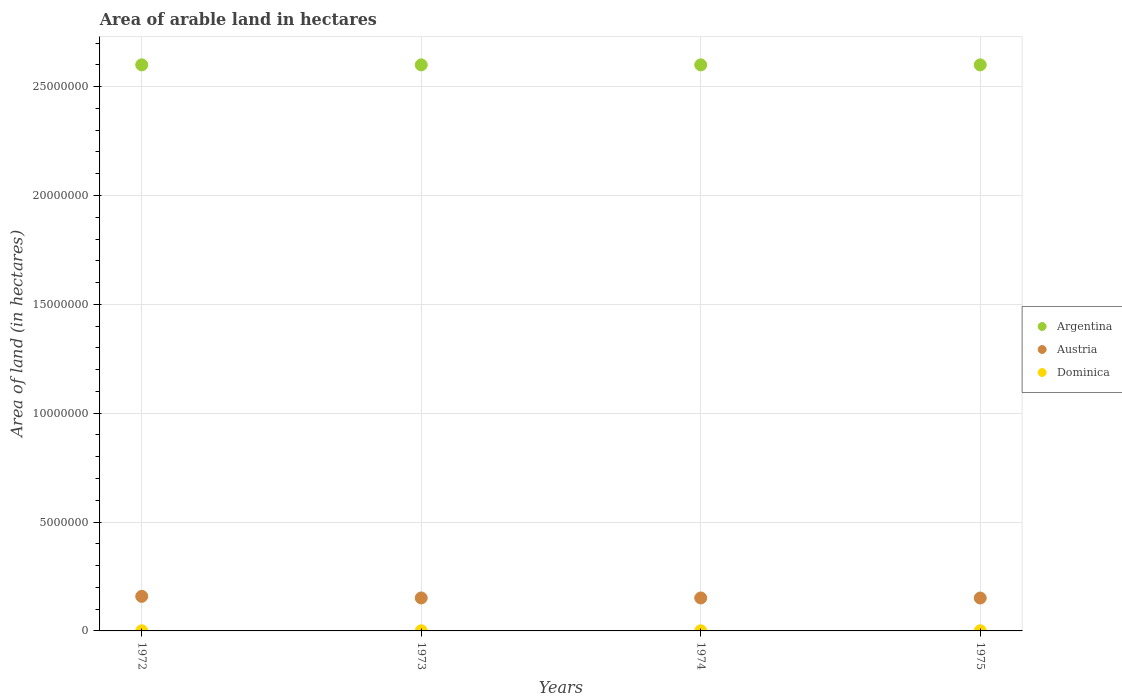How many different coloured dotlines are there?
Your response must be concise. 3. What is the total arable land in Dominica in 1974?
Provide a short and direct response. 7000. Across all years, what is the maximum total arable land in Argentina?
Your response must be concise. 2.60e+07. Across all years, what is the minimum total arable land in Dominica?
Your response must be concise. 7000. In which year was the total arable land in Austria minimum?
Provide a short and direct response. 1975. What is the total total arable land in Argentina in the graph?
Give a very brief answer. 1.04e+08. What is the difference between the total arable land in Dominica in 1973 and the total arable land in Austria in 1972?
Make the answer very short. -1.58e+06. What is the average total arable land in Austria per year?
Provide a succinct answer. 1.53e+06. In the year 1972, what is the difference between the total arable land in Austria and total arable land in Dominica?
Your answer should be compact. 1.58e+06. Is the total arable land in Argentina in 1974 less than that in 1975?
Your answer should be very brief. No. Is the difference between the total arable land in Austria in 1974 and 1975 greater than the difference between the total arable land in Dominica in 1974 and 1975?
Offer a very short reply. Yes. What is the difference between the highest and the lowest total arable land in Argentina?
Ensure brevity in your answer.  0. Is the total arable land in Argentina strictly less than the total arable land in Austria over the years?
Provide a short and direct response. No. How many dotlines are there?
Keep it short and to the point. 3. Does the graph contain any zero values?
Offer a very short reply. No. Does the graph contain grids?
Make the answer very short. Yes. Where does the legend appear in the graph?
Your response must be concise. Center right. What is the title of the graph?
Your response must be concise. Area of arable land in hectares. Does "Sri Lanka" appear as one of the legend labels in the graph?
Keep it short and to the point. No. What is the label or title of the X-axis?
Keep it short and to the point. Years. What is the label or title of the Y-axis?
Make the answer very short. Area of land (in hectares). What is the Area of land (in hectares) in Argentina in 1972?
Offer a very short reply. 2.60e+07. What is the Area of land (in hectares) in Austria in 1972?
Your answer should be compact. 1.59e+06. What is the Area of land (in hectares) of Dominica in 1972?
Your answer should be compact. 7000. What is the Area of land (in hectares) in Argentina in 1973?
Provide a succinct answer. 2.60e+07. What is the Area of land (in hectares) of Austria in 1973?
Ensure brevity in your answer.  1.51e+06. What is the Area of land (in hectares) of Dominica in 1973?
Provide a succinct answer. 7000. What is the Area of land (in hectares) of Argentina in 1974?
Offer a terse response. 2.60e+07. What is the Area of land (in hectares) in Austria in 1974?
Your answer should be very brief. 1.51e+06. What is the Area of land (in hectares) of Dominica in 1974?
Your response must be concise. 7000. What is the Area of land (in hectares) of Argentina in 1975?
Your answer should be compact. 2.60e+07. What is the Area of land (in hectares) in Austria in 1975?
Make the answer very short. 1.51e+06. What is the Area of land (in hectares) of Dominica in 1975?
Offer a very short reply. 7000. Across all years, what is the maximum Area of land (in hectares) of Argentina?
Keep it short and to the point. 2.60e+07. Across all years, what is the maximum Area of land (in hectares) in Austria?
Keep it short and to the point. 1.59e+06. Across all years, what is the maximum Area of land (in hectares) in Dominica?
Give a very brief answer. 7000. Across all years, what is the minimum Area of land (in hectares) in Argentina?
Provide a succinct answer. 2.60e+07. Across all years, what is the minimum Area of land (in hectares) in Austria?
Offer a very short reply. 1.51e+06. Across all years, what is the minimum Area of land (in hectares) of Dominica?
Keep it short and to the point. 7000. What is the total Area of land (in hectares) in Argentina in the graph?
Make the answer very short. 1.04e+08. What is the total Area of land (in hectares) of Austria in the graph?
Your response must be concise. 6.13e+06. What is the total Area of land (in hectares) of Dominica in the graph?
Your response must be concise. 2.80e+04. What is the difference between the Area of land (in hectares) in Argentina in 1972 and that in 1973?
Ensure brevity in your answer.  0. What is the difference between the Area of land (in hectares) of Austria in 1972 and that in 1973?
Offer a very short reply. 7.40e+04. What is the difference between the Area of land (in hectares) in Argentina in 1972 and that in 1974?
Your answer should be very brief. 0. What is the difference between the Area of land (in hectares) in Austria in 1972 and that in 1974?
Ensure brevity in your answer.  7.40e+04. What is the difference between the Area of land (in hectares) of Argentina in 1972 and that in 1975?
Provide a short and direct response. 0. What is the difference between the Area of land (in hectares) in Austria in 1972 and that in 1975?
Your answer should be very brief. 7.70e+04. What is the difference between the Area of land (in hectares) of Dominica in 1972 and that in 1975?
Make the answer very short. 0. What is the difference between the Area of land (in hectares) of Dominica in 1973 and that in 1974?
Give a very brief answer. 0. What is the difference between the Area of land (in hectares) in Austria in 1973 and that in 1975?
Keep it short and to the point. 3000. What is the difference between the Area of land (in hectares) of Austria in 1974 and that in 1975?
Your answer should be compact. 3000. What is the difference between the Area of land (in hectares) of Argentina in 1972 and the Area of land (in hectares) of Austria in 1973?
Keep it short and to the point. 2.45e+07. What is the difference between the Area of land (in hectares) of Argentina in 1972 and the Area of land (in hectares) of Dominica in 1973?
Your answer should be very brief. 2.60e+07. What is the difference between the Area of land (in hectares) of Austria in 1972 and the Area of land (in hectares) of Dominica in 1973?
Your answer should be compact. 1.58e+06. What is the difference between the Area of land (in hectares) of Argentina in 1972 and the Area of land (in hectares) of Austria in 1974?
Your answer should be compact. 2.45e+07. What is the difference between the Area of land (in hectares) in Argentina in 1972 and the Area of land (in hectares) in Dominica in 1974?
Give a very brief answer. 2.60e+07. What is the difference between the Area of land (in hectares) in Austria in 1972 and the Area of land (in hectares) in Dominica in 1974?
Your response must be concise. 1.58e+06. What is the difference between the Area of land (in hectares) of Argentina in 1972 and the Area of land (in hectares) of Austria in 1975?
Your answer should be compact. 2.45e+07. What is the difference between the Area of land (in hectares) of Argentina in 1972 and the Area of land (in hectares) of Dominica in 1975?
Your answer should be very brief. 2.60e+07. What is the difference between the Area of land (in hectares) of Austria in 1972 and the Area of land (in hectares) of Dominica in 1975?
Your answer should be very brief. 1.58e+06. What is the difference between the Area of land (in hectares) in Argentina in 1973 and the Area of land (in hectares) in Austria in 1974?
Keep it short and to the point. 2.45e+07. What is the difference between the Area of land (in hectares) in Argentina in 1973 and the Area of land (in hectares) in Dominica in 1974?
Give a very brief answer. 2.60e+07. What is the difference between the Area of land (in hectares) in Austria in 1973 and the Area of land (in hectares) in Dominica in 1974?
Provide a short and direct response. 1.51e+06. What is the difference between the Area of land (in hectares) in Argentina in 1973 and the Area of land (in hectares) in Austria in 1975?
Give a very brief answer. 2.45e+07. What is the difference between the Area of land (in hectares) of Argentina in 1973 and the Area of land (in hectares) of Dominica in 1975?
Give a very brief answer. 2.60e+07. What is the difference between the Area of land (in hectares) in Austria in 1973 and the Area of land (in hectares) in Dominica in 1975?
Provide a succinct answer. 1.51e+06. What is the difference between the Area of land (in hectares) in Argentina in 1974 and the Area of land (in hectares) in Austria in 1975?
Make the answer very short. 2.45e+07. What is the difference between the Area of land (in hectares) of Argentina in 1974 and the Area of land (in hectares) of Dominica in 1975?
Your response must be concise. 2.60e+07. What is the difference between the Area of land (in hectares) in Austria in 1974 and the Area of land (in hectares) in Dominica in 1975?
Provide a short and direct response. 1.51e+06. What is the average Area of land (in hectares) in Argentina per year?
Offer a terse response. 2.60e+07. What is the average Area of land (in hectares) in Austria per year?
Provide a short and direct response. 1.53e+06. What is the average Area of land (in hectares) in Dominica per year?
Offer a terse response. 7000. In the year 1972, what is the difference between the Area of land (in hectares) in Argentina and Area of land (in hectares) in Austria?
Offer a terse response. 2.44e+07. In the year 1972, what is the difference between the Area of land (in hectares) in Argentina and Area of land (in hectares) in Dominica?
Your answer should be compact. 2.60e+07. In the year 1972, what is the difference between the Area of land (in hectares) of Austria and Area of land (in hectares) of Dominica?
Give a very brief answer. 1.58e+06. In the year 1973, what is the difference between the Area of land (in hectares) of Argentina and Area of land (in hectares) of Austria?
Offer a very short reply. 2.45e+07. In the year 1973, what is the difference between the Area of land (in hectares) in Argentina and Area of land (in hectares) in Dominica?
Your answer should be very brief. 2.60e+07. In the year 1973, what is the difference between the Area of land (in hectares) of Austria and Area of land (in hectares) of Dominica?
Your response must be concise. 1.51e+06. In the year 1974, what is the difference between the Area of land (in hectares) in Argentina and Area of land (in hectares) in Austria?
Keep it short and to the point. 2.45e+07. In the year 1974, what is the difference between the Area of land (in hectares) of Argentina and Area of land (in hectares) of Dominica?
Offer a very short reply. 2.60e+07. In the year 1974, what is the difference between the Area of land (in hectares) of Austria and Area of land (in hectares) of Dominica?
Provide a succinct answer. 1.51e+06. In the year 1975, what is the difference between the Area of land (in hectares) in Argentina and Area of land (in hectares) in Austria?
Your response must be concise. 2.45e+07. In the year 1975, what is the difference between the Area of land (in hectares) in Argentina and Area of land (in hectares) in Dominica?
Keep it short and to the point. 2.60e+07. In the year 1975, what is the difference between the Area of land (in hectares) in Austria and Area of land (in hectares) in Dominica?
Ensure brevity in your answer.  1.50e+06. What is the ratio of the Area of land (in hectares) in Argentina in 1972 to that in 1973?
Make the answer very short. 1. What is the ratio of the Area of land (in hectares) of Austria in 1972 to that in 1973?
Ensure brevity in your answer.  1.05. What is the ratio of the Area of land (in hectares) of Dominica in 1972 to that in 1973?
Ensure brevity in your answer.  1. What is the ratio of the Area of land (in hectares) of Argentina in 1972 to that in 1974?
Offer a very short reply. 1. What is the ratio of the Area of land (in hectares) of Austria in 1972 to that in 1974?
Keep it short and to the point. 1.05. What is the ratio of the Area of land (in hectares) of Dominica in 1972 to that in 1974?
Provide a succinct answer. 1. What is the ratio of the Area of land (in hectares) in Austria in 1972 to that in 1975?
Make the answer very short. 1.05. What is the ratio of the Area of land (in hectares) of Argentina in 1973 to that in 1974?
Provide a short and direct response. 1. What is the ratio of the Area of land (in hectares) of Austria in 1973 to that in 1974?
Provide a short and direct response. 1. What is the ratio of the Area of land (in hectares) in Argentina in 1974 to that in 1975?
Your answer should be compact. 1. What is the ratio of the Area of land (in hectares) of Austria in 1974 to that in 1975?
Provide a short and direct response. 1. What is the ratio of the Area of land (in hectares) in Dominica in 1974 to that in 1975?
Your answer should be very brief. 1. What is the difference between the highest and the second highest Area of land (in hectares) of Austria?
Provide a short and direct response. 7.40e+04. What is the difference between the highest and the second highest Area of land (in hectares) of Dominica?
Make the answer very short. 0. What is the difference between the highest and the lowest Area of land (in hectares) in Austria?
Your response must be concise. 7.70e+04. What is the difference between the highest and the lowest Area of land (in hectares) in Dominica?
Keep it short and to the point. 0. 